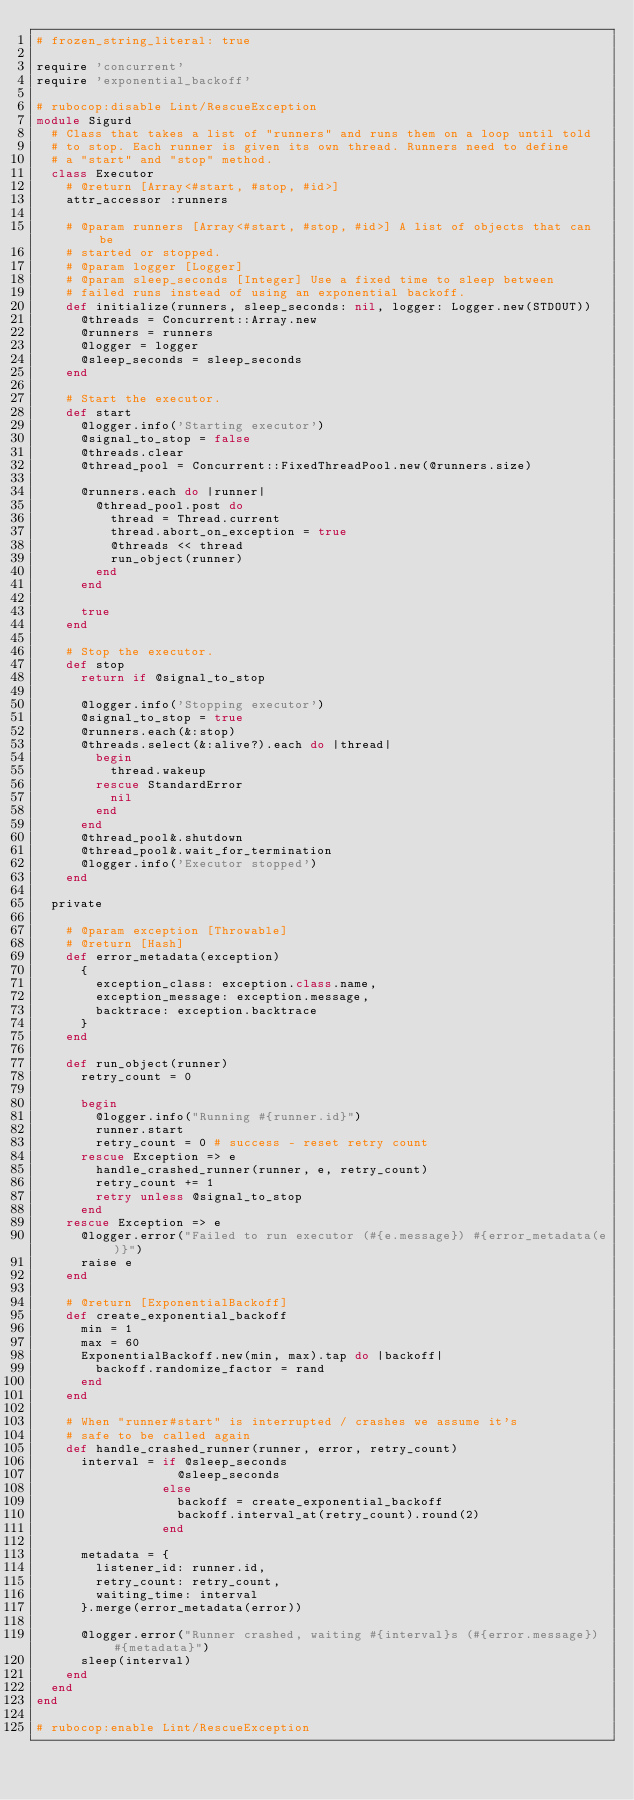<code> <loc_0><loc_0><loc_500><loc_500><_Ruby_># frozen_string_literal: true

require 'concurrent'
require 'exponential_backoff'

# rubocop:disable Lint/RescueException
module Sigurd
  # Class that takes a list of "runners" and runs them on a loop until told
  # to stop. Each runner is given its own thread. Runners need to define
  # a "start" and "stop" method.
  class Executor
    # @return [Array<#start, #stop, #id>]
    attr_accessor :runners

    # @param runners [Array<#start, #stop, #id>] A list of objects that can be
    # started or stopped.
    # @param logger [Logger]
    # @param sleep_seconds [Integer] Use a fixed time to sleep between
    # failed runs instead of using an exponential backoff.
    def initialize(runners, sleep_seconds: nil, logger: Logger.new(STDOUT))
      @threads = Concurrent::Array.new
      @runners = runners
      @logger = logger
      @sleep_seconds = sleep_seconds
    end

    # Start the executor.
    def start
      @logger.info('Starting executor')
      @signal_to_stop = false
      @threads.clear
      @thread_pool = Concurrent::FixedThreadPool.new(@runners.size)

      @runners.each do |runner|
        @thread_pool.post do
          thread = Thread.current
          thread.abort_on_exception = true
          @threads << thread
          run_object(runner)
        end
      end

      true
    end

    # Stop the executor.
    def stop
      return if @signal_to_stop

      @logger.info('Stopping executor')
      @signal_to_stop = true
      @runners.each(&:stop)
      @threads.select(&:alive?).each do |thread|
        begin
          thread.wakeup
        rescue StandardError
          nil
        end
      end
      @thread_pool&.shutdown
      @thread_pool&.wait_for_termination
      @logger.info('Executor stopped')
    end

  private

    # @param exception [Throwable]
    # @return [Hash]
    def error_metadata(exception)
      {
        exception_class: exception.class.name,
        exception_message: exception.message,
        backtrace: exception.backtrace
      }
    end

    def run_object(runner)
      retry_count = 0

      begin
        @logger.info("Running #{runner.id}")
        runner.start
        retry_count = 0 # success - reset retry count
      rescue Exception => e
        handle_crashed_runner(runner, e, retry_count)
        retry_count += 1
        retry unless @signal_to_stop
      end
    rescue Exception => e
      @logger.error("Failed to run executor (#{e.message}) #{error_metadata(e)}")
      raise e
    end

    # @return [ExponentialBackoff]
    def create_exponential_backoff
      min = 1
      max = 60
      ExponentialBackoff.new(min, max).tap do |backoff|
        backoff.randomize_factor = rand
      end
    end

    # When "runner#start" is interrupted / crashes we assume it's
    # safe to be called again
    def handle_crashed_runner(runner, error, retry_count)
      interval = if @sleep_seconds
                   @sleep_seconds
                 else
                   backoff = create_exponential_backoff
                   backoff.interval_at(retry_count).round(2)
                 end

      metadata = {
        listener_id: runner.id,
        retry_count: retry_count,
        waiting_time: interval
      }.merge(error_metadata(error))

      @logger.error("Runner crashed, waiting #{interval}s (#{error.message}) #{metadata}")
      sleep(interval)
    end
  end
end

# rubocop:enable Lint/RescueException
</code> 